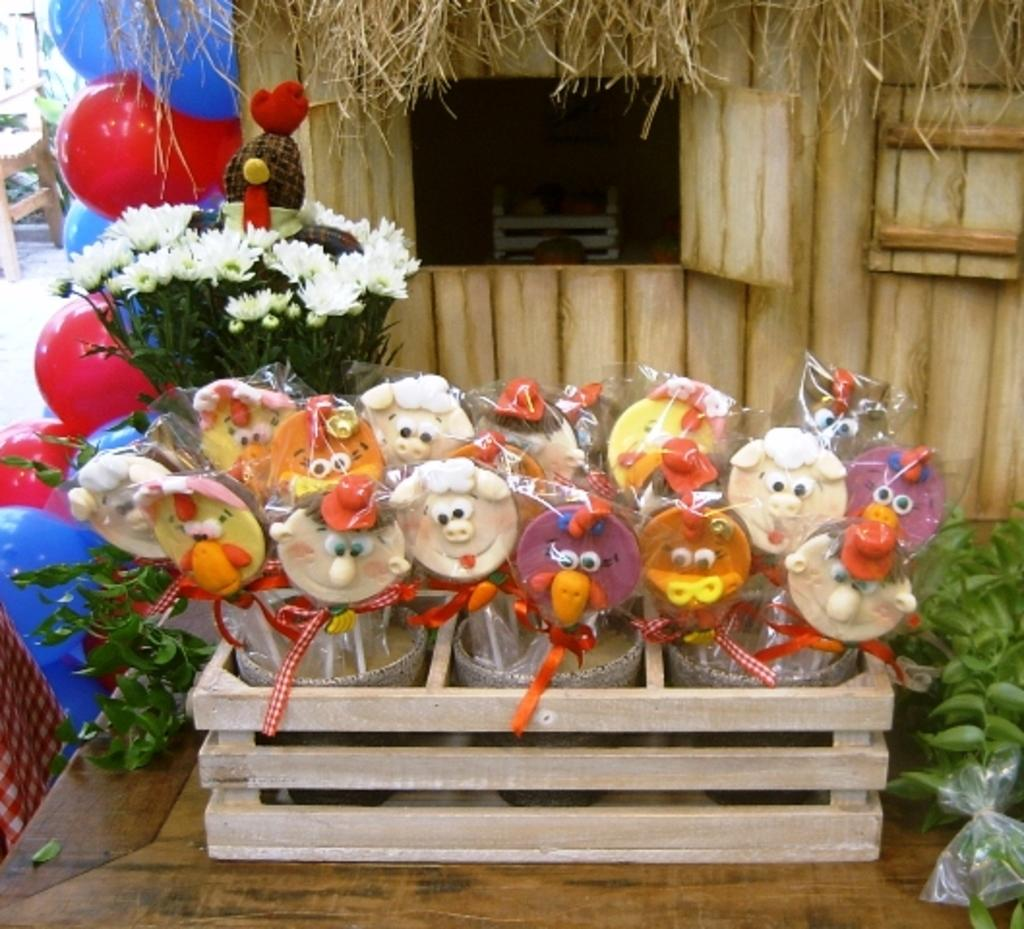What type of confectionery is present in the image? There are colorful candies in the image. What other objects can be seen in the image? There are plants, a bouquet, red and blue balloons, and a wooden box in the image. What is the color of the surface on which the candies are placed? The candies are on a brown surface. What level of water can be seen in the vessel in the image? There is no vessel or water present in the image. Where is the home located in the image? There is no home present in the image. 